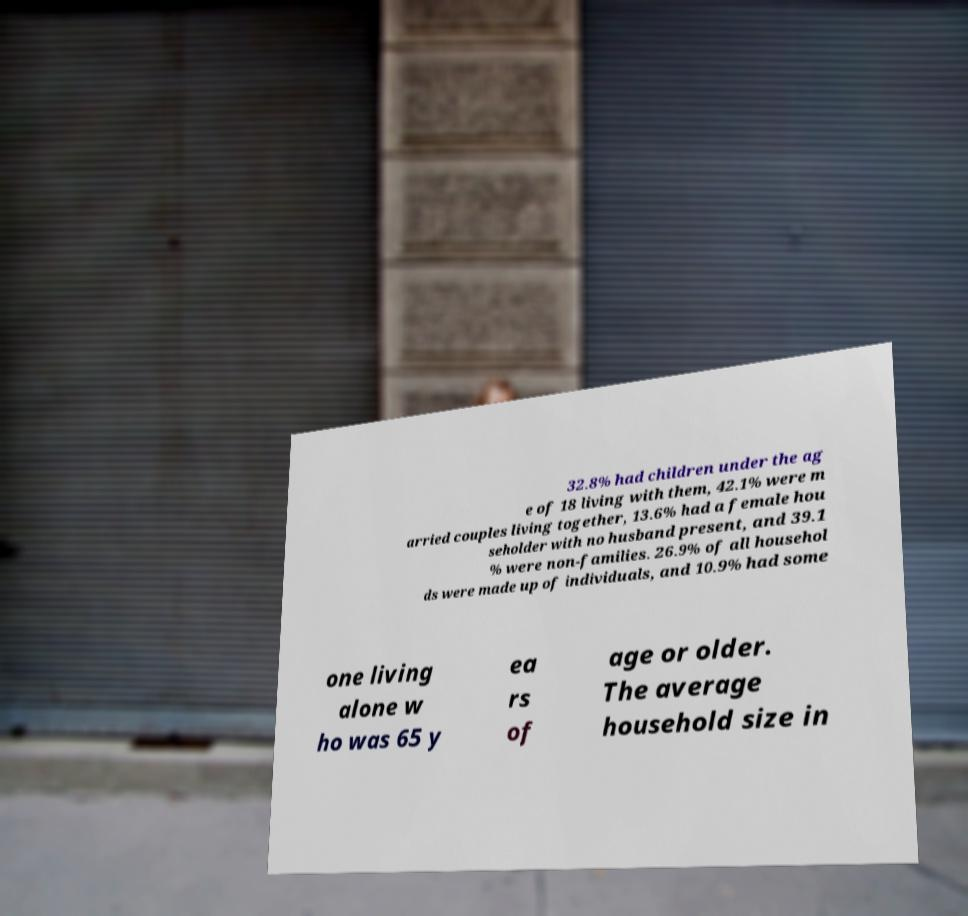I need the written content from this picture converted into text. Can you do that? 32.8% had children under the ag e of 18 living with them, 42.1% were m arried couples living together, 13.6% had a female hou seholder with no husband present, and 39.1 % were non-families. 26.9% of all househol ds were made up of individuals, and 10.9% had some one living alone w ho was 65 y ea rs of age or older. The average household size in 